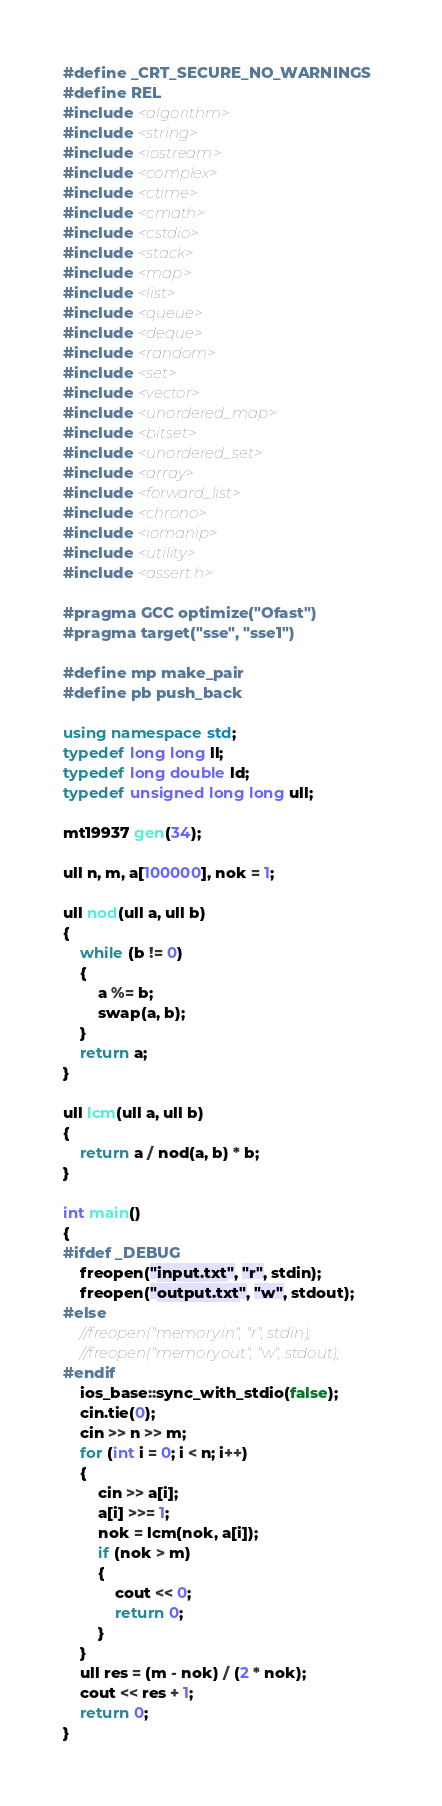<code> <loc_0><loc_0><loc_500><loc_500><_C++_>#define _CRT_SECURE_NO_WARNINGS
#define REL
#include <algorithm>
#include <string>
#include <iostream>
#include <complex>
#include <ctime>
#include <cmath>
#include <cstdio>
#include <stack>
#include <map>
#include <list>
#include <queue>
#include <deque>
#include <random>
#include <set>
#include <vector>
#include <unordered_map>
#include <bitset>
#include <unordered_set>
#include <array>
#include <forward_list>
#include <chrono>
#include <iomanip>
#include <utility>
#include <assert.h>

#pragma GCC optimize("Ofast")
#pragma target("sse", "sse1")

#define mp make_pair
#define pb push_back

using namespace std;
typedef long long ll;
typedef long double ld;
typedef unsigned long long ull;

mt19937 gen(34);

ull n, m, a[100000], nok = 1;

ull nod(ull a, ull b)
{
	while (b != 0)
	{
		a %= b;
		swap(a, b);
	}
	return a;
}

ull lcm(ull a, ull b)
{
	return a / nod(a, b) * b;
}

int main()
{
#ifdef _DEBUG
	freopen("input.txt", "r", stdin);
	freopen("output.txt", "w", stdout);
#else
	//freopen("memory.in", "r", stdin);
	//freopen("memory.out", "w", stdout);
#endif
	ios_base::sync_with_stdio(false);
	cin.tie(0);
	cin >> n >> m;
	for (int i = 0; i < n; i++)
	{
		cin >> a[i];
		a[i] >>= 1;
		nok = lcm(nok, a[i]);
		if (nok > m)
		{
			cout << 0;
			return 0;
		}
	}
	ull res = (m - nok) / (2 * nok);
	cout << res + 1;
	return 0;
}</code> 